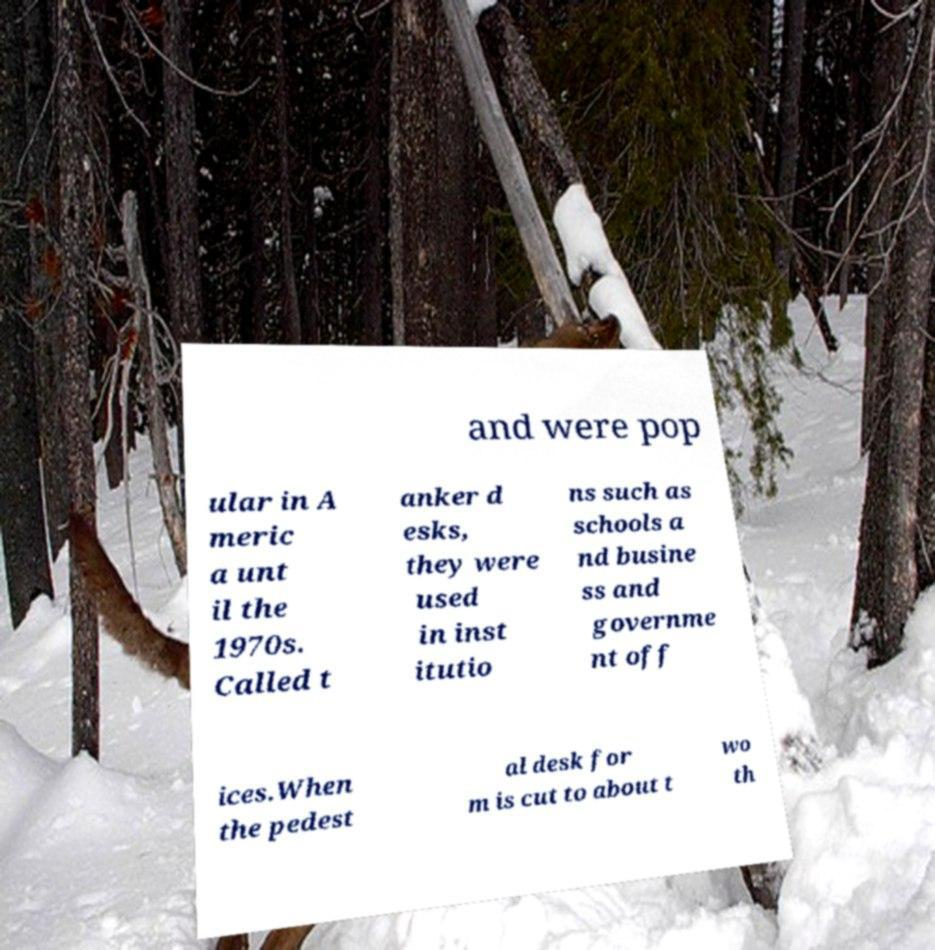What messages or text are displayed in this image? I need them in a readable, typed format. and were pop ular in A meric a unt il the 1970s. Called t anker d esks, they were used in inst itutio ns such as schools a nd busine ss and governme nt off ices.When the pedest al desk for m is cut to about t wo th 